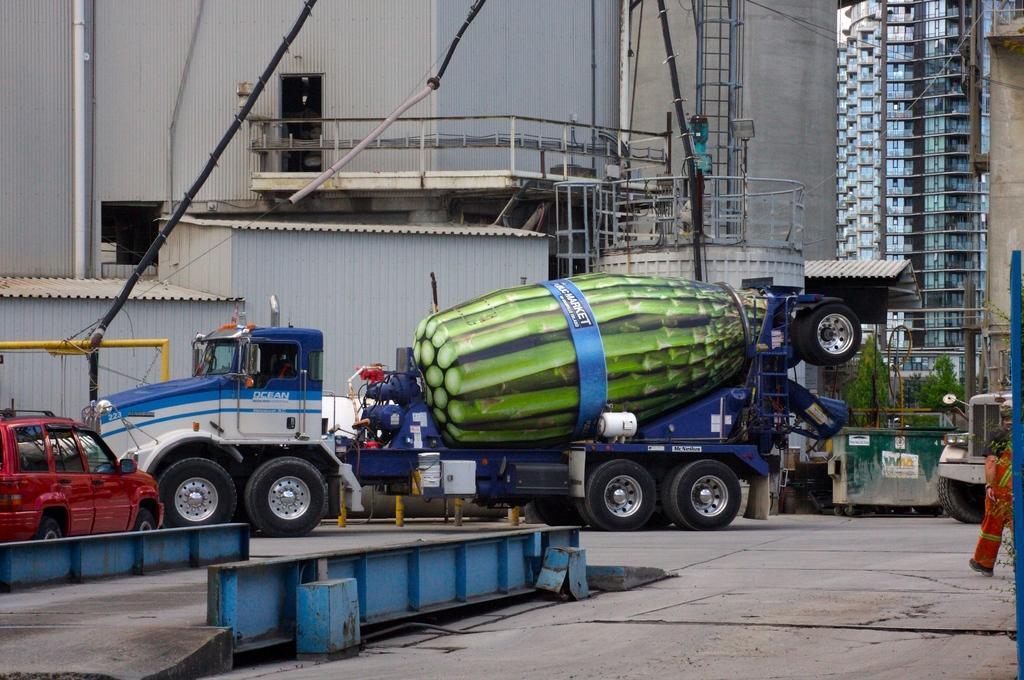Can you describe this image briefly? In this picture there is a truck in the center of the image, on which there is a big model of a bottle and there is a car on the left side of the image and there is a jeep on the right side of the image and, there are towers and buildings in the background area of the image. 